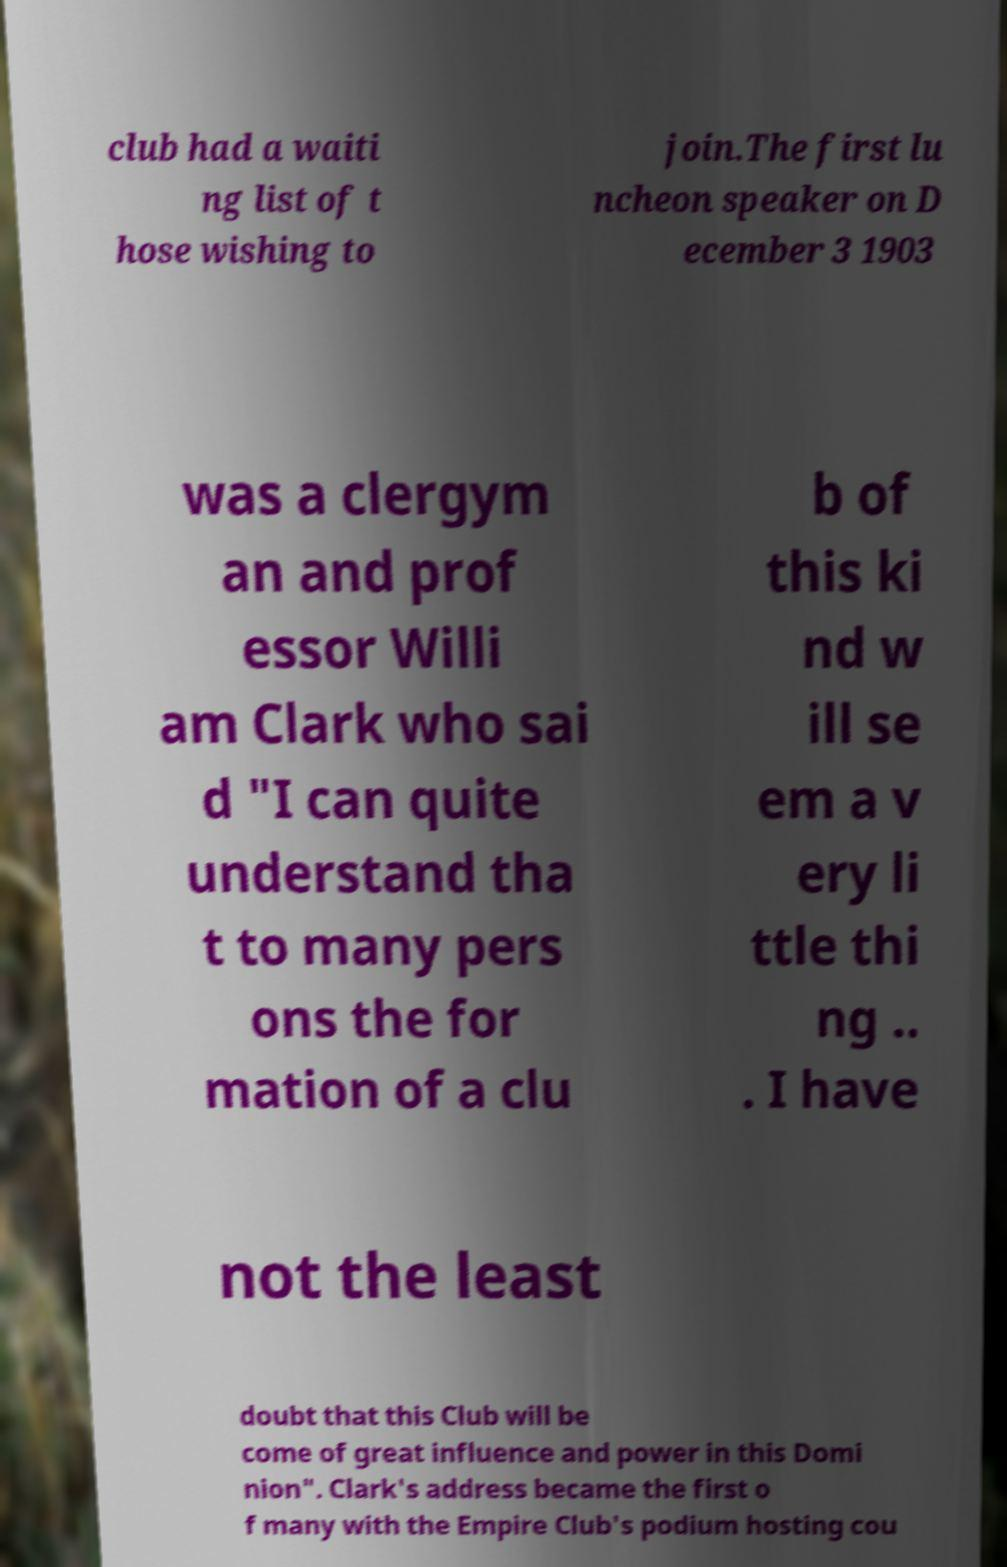Can you read and provide the text displayed in the image?This photo seems to have some interesting text. Can you extract and type it out for me? club had a waiti ng list of t hose wishing to join.The first lu ncheon speaker on D ecember 3 1903 was a clergym an and prof essor Willi am Clark who sai d "I can quite understand tha t to many pers ons the for mation of a clu b of this ki nd w ill se em a v ery li ttle thi ng .. . I have not the least doubt that this Club will be come of great influence and power in this Domi nion". Clark's address became the first o f many with the Empire Club's podium hosting cou 